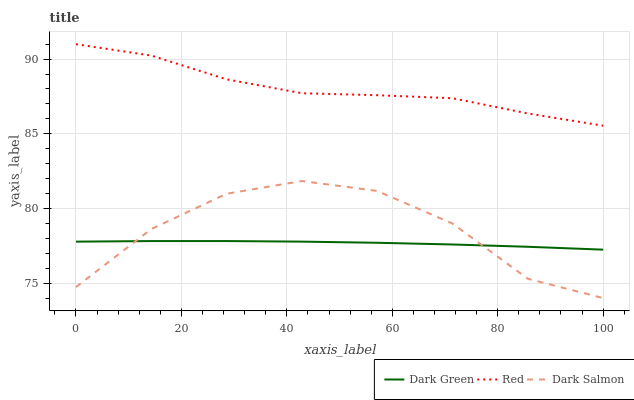Does Dark Green have the minimum area under the curve?
Answer yes or no. Yes. Does Red have the maximum area under the curve?
Answer yes or no. Yes. Does Red have the minimum area under the curve?
Answer yes or no. No. Does Dark Green have the maximum area under the curve?
Answer yes or no. No. Is Dark Green the smoothest?
Answer yes or no. Yes. Is Dark Salmon the roughest?
Answer yes or no. Yes. Is Red the smoothest?
Answer yes or no. No. Is Red the roughest?
Answer yes or no. No. Does Dark Green have the lowest value?
Answer yes or no. No. Does Dark Green have the highest value?
Answer yes or no. No. Is Dark Salmon less than Red?
Answer yes or no. Yes. Is Red greater than Dark Salmon?
Answer yes or no. Yes. Does Dark Salmon intersect Red?
Answer yes or no. No. 